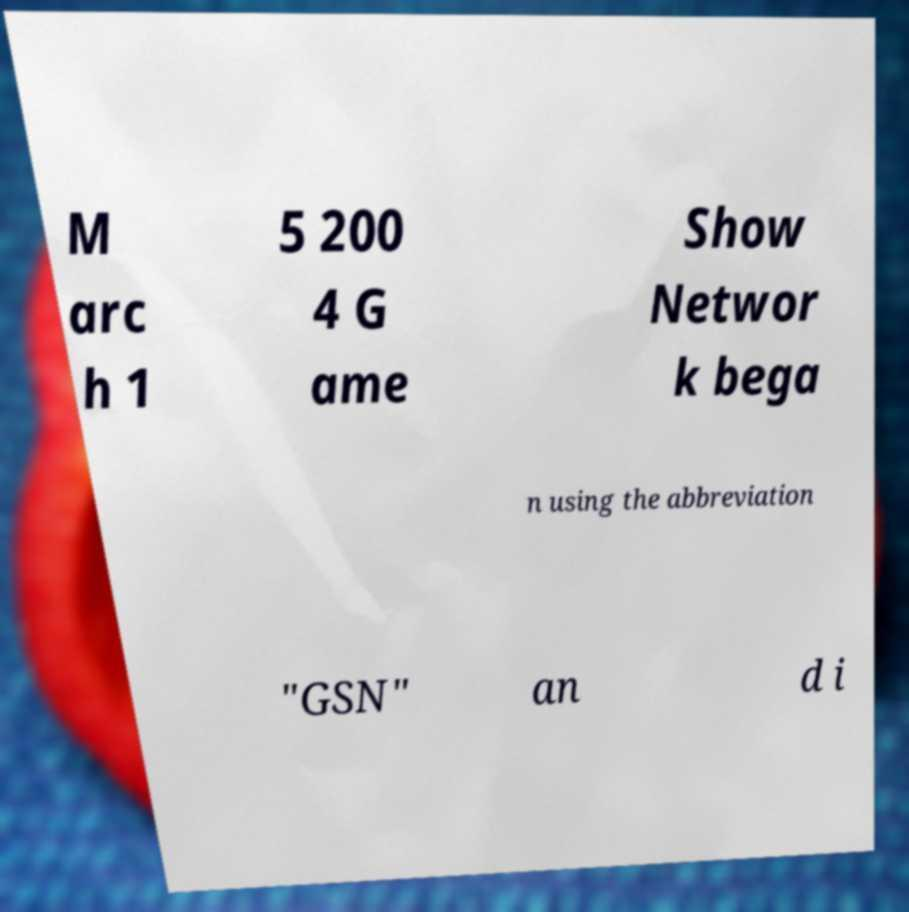Please identify and transcribe the text found in this image. M arc h 1 5 200 4 G ame Show Networ k bega n using the abbreviation "GSN" an d i 